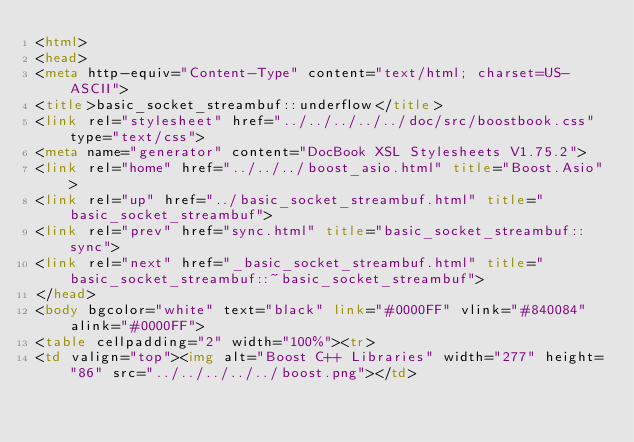<code> <loc_0><loc_0><loc_500><loc_500><_HTML_><html>
<head>
<meta http-equiv="Content-Type" content="text/html; charset=US-ASCII">
<title>basic_socket_streambuf::underflow</title>
<link rel="stylesheet" href="../../../../../doc/src/boostbook.css" type="text/css">
<meta name="generator" content="DocBook XSL Stylesheets V1.75.2">
<link rel="home" href="../../../boost_asio.html" title="Boost.Asio">
<link rel="up" href="../basic_socket_streambuf.html" title="basic_socket_streambuf">
<link rel="prev" href="sync.html" title="basic_socket_streambuf::sync">
<link rel="next" href="_basic_socket_streambuf.html" title="basic_socket_streambuf::~basic_socket_streambuf">
</head>
<body bgcolor="white" text="black" link="#0000FF" vlink="#840084" alink="#0000FF">
<table cellpadding="2" width="100%"><tr>
<td valign="top"><img alt="Boost C++ Libraries" width="277" height="86" src="../../../../../boost.png"></td></code> 